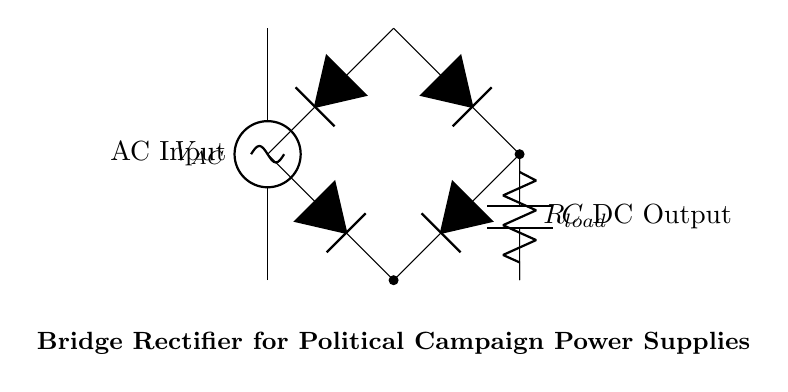What type of circuit is shown in the diagram? The diagram depicts a bridge rectifier circuit, which is specifically designed to convert alternating current (AC) to direct current (DC). This can be identified by the arrangement of diodes forming a bridge configuration.
Answer: Bridge rectifier How many diodes are used in the bridge rectifier? In the circuit, there are four diodes arranged in a bridge configuration. This is a standard setup for a bridge rectifier, allowing it to convert AC to DC efficiently.
Answer: Four What is the purpose of the capacitor in the circuit? The capacitor's role is to smoothen the output voltage by filtering out the ripples that arise from the rectification process. This helps to provide a more stable DC output for the load connected.
Answer: Smooth output voltage What is the load component labeled as in the diagram? The load in the circuit is labeled as R load, which represents the resistance connected to the rectified output. This load would draw current from the DC output.
Answer: R load What does the AC input represent in the circuit? The AC input is represented by the voltage source labeled V AC, which supplies alternating current to the bridge rectifier for conversion to direct current.
Answer: V AC Which components form the bridge configuration in the rectifier? The bridge configuration consists of all four diodes in the circuit. These diodes are arranged in such a way that they allow both halves of the AC waveform to be used for rectification.
Answer: Four diodes 